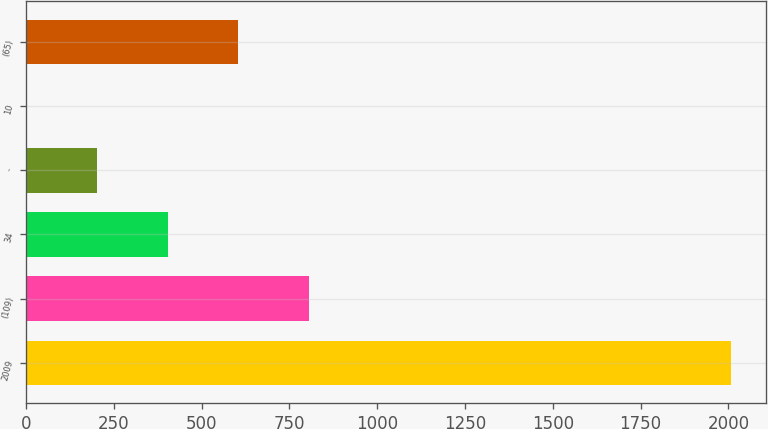<chart> <loc_0><loc_0><loc_500><loc_500><bar_chart><fcel>2009<fcel>(109)<fcel>34<fcel>-<fcel>10<fcel>(65)<nl><fcel>2008<fcel>804.4<fcel>403.2<fcel>202.6<fcel>2<fcel>603.8<nl></chart> 